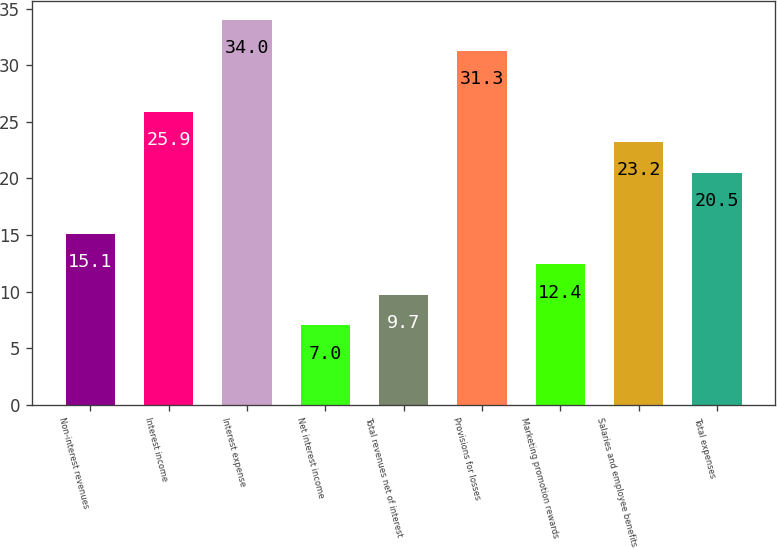<chart> <loc_0><loc_0><loc_500><loc_500><bar_chart><fcel>Non-interest revenues<fcel>Interest income<fcel>Interest expense<fcel>Net interest income<fcel>Total revenues net of interest<fcel>Provisions for losses<fcel>Marketing promotion rewards<fcel>Salaries and employee benefits<fcel>Total expenses<nl><fcel>15.1<fcel>25.9<fcel>34<fcel>7<fcel>9.7<fcel>31.3<fcel>12.4<fcel>23.2<fcel>20.5<nl></chart> 